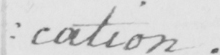Please provide the text content of this handwritten line. : cation . 